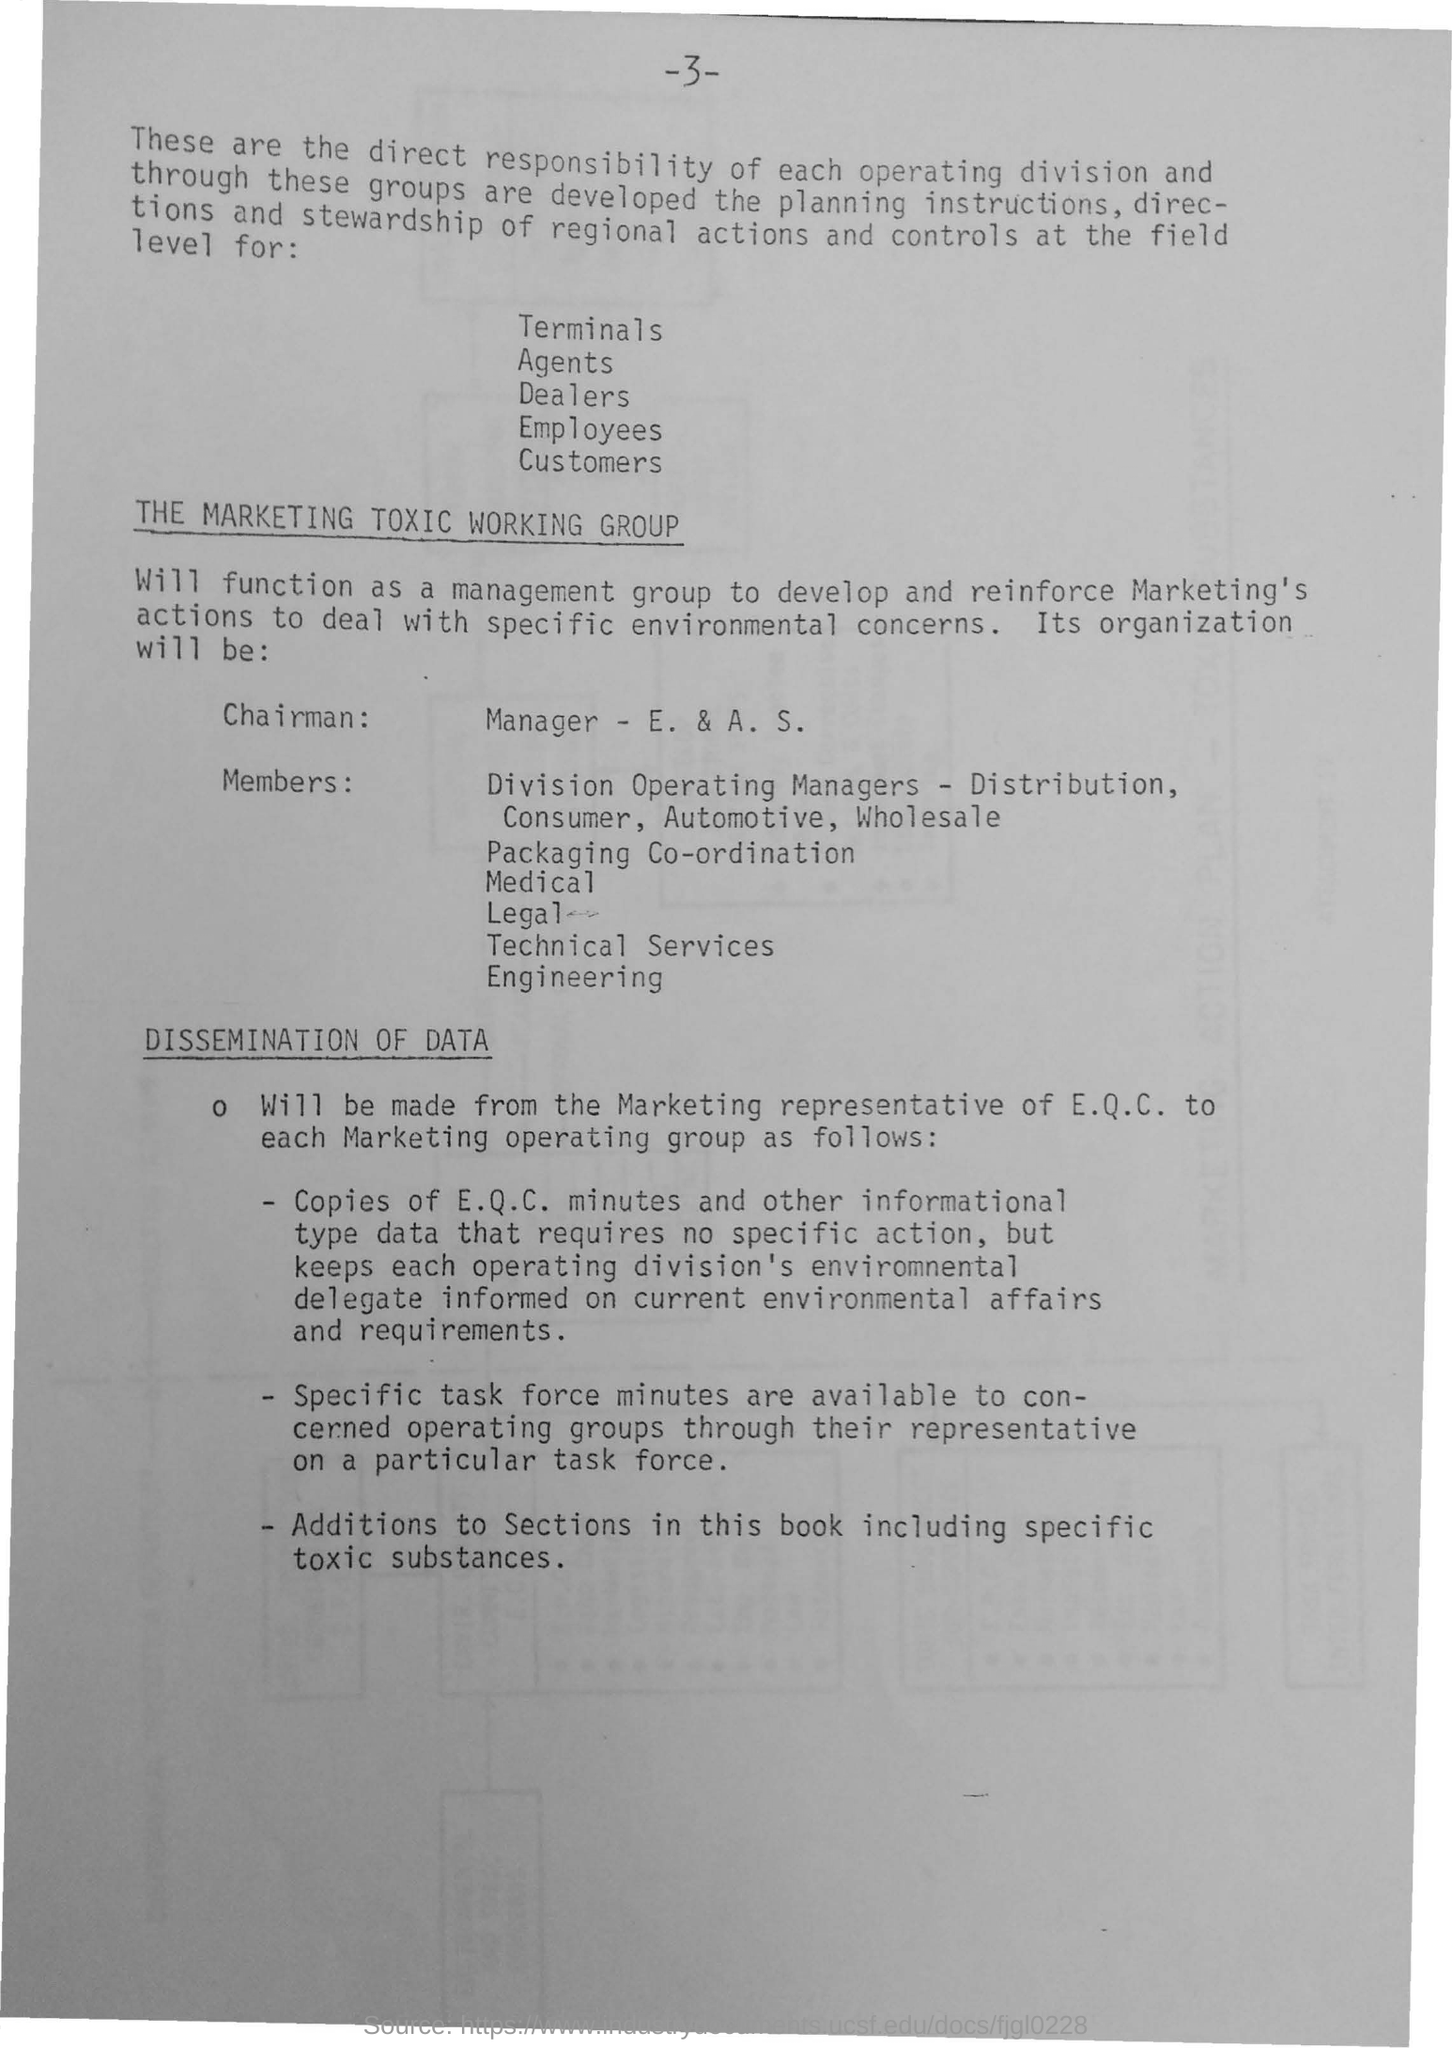What is the first title in the document?
Your answer should be compact. The Marketing Toxic Working Group. What is the second title in this document?
Offer a terse response. Dissemination of Data. 